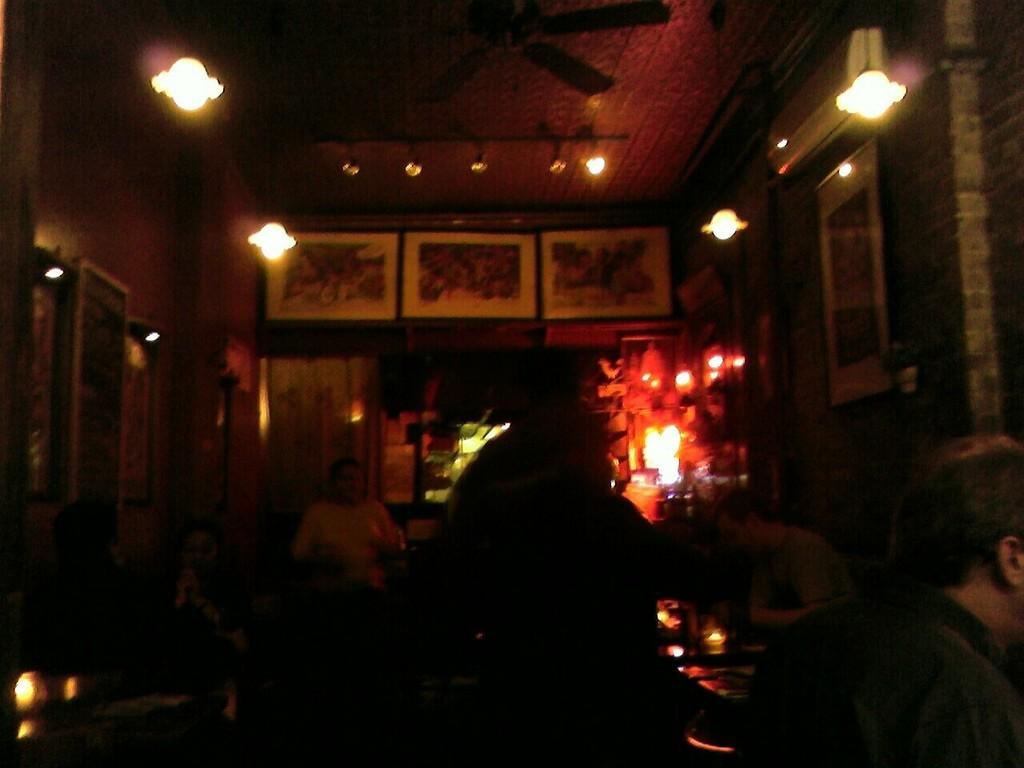How would you summarize this image in a sentence or two? This picture shows the inner view of a building. There are some lights, one fan attached to the ceiling. There are some photo frames, one AC, some lights and some objects attached to the wall. One curtain attached to the door, some objects are on the surface, some light lamps on the table, some people are sitting on the chairs and some objects are on the table. 